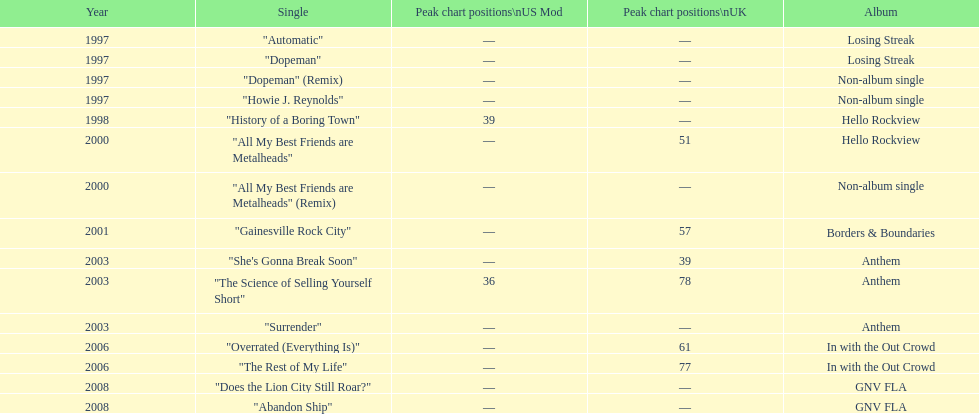What is an additional solo song featured on the "losing streak" album besides "dopeman"? "Automatic". 